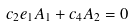<formula> <loc_0><loc_0><loc_500><loc_500>c _ { 2 } e _ { 1 } A _ { 1 } + c _ { 4 } A _ { 2 } & = 0</formula> 